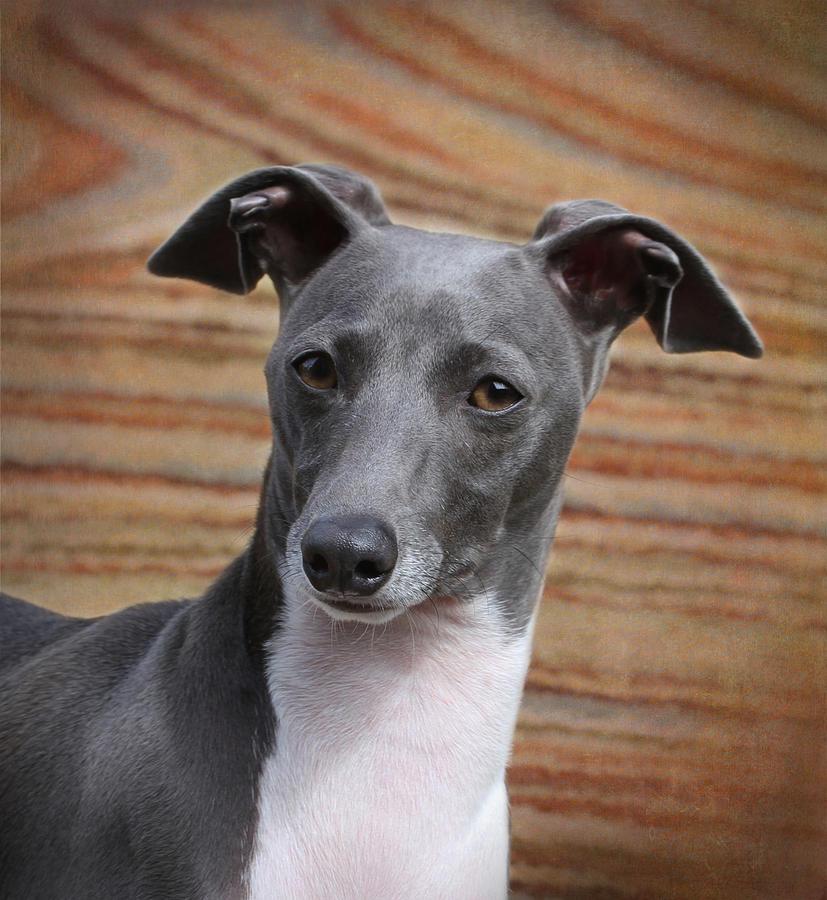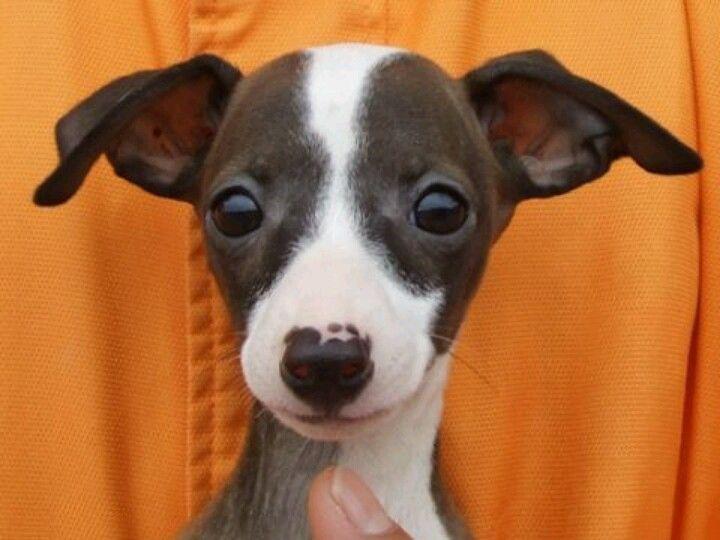The first image is the image on the left, the second image is the image on the right. Evaluate the accuracy of this statement regarding the images: "Each image contains a single dog, and all dogs are charcoal gray with white markings.". Is it true? Answer yes or no. Yes. The first image is the image on the left, the second image is the image on the right. For the images shown, is this caption "There is a dog posing near some green leaves." true? Answer yes or no. No. 